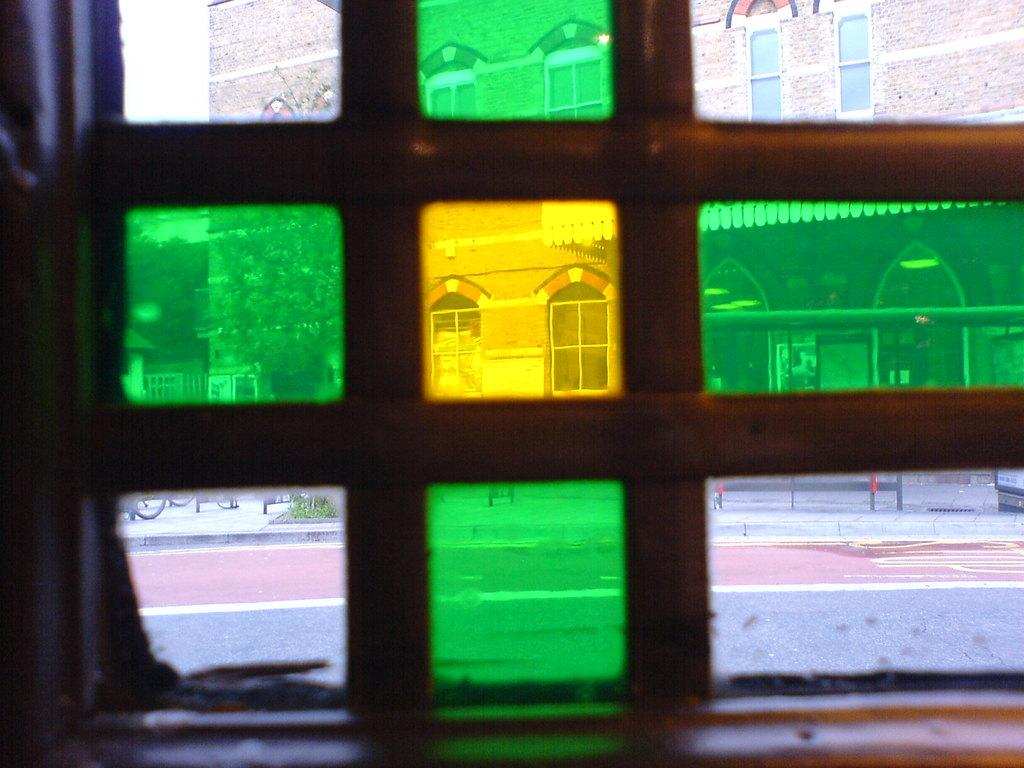What is located at the bottom of the image? There is a window at the bottom of the image. What can be seen through the window? A building and trees are visible through the window. Where is the river located in the image? There is no river present in the image. What type of activity is taking place in the image? The image does not depict any specific activity; it primarily shows a window with a view of a building and trees. 